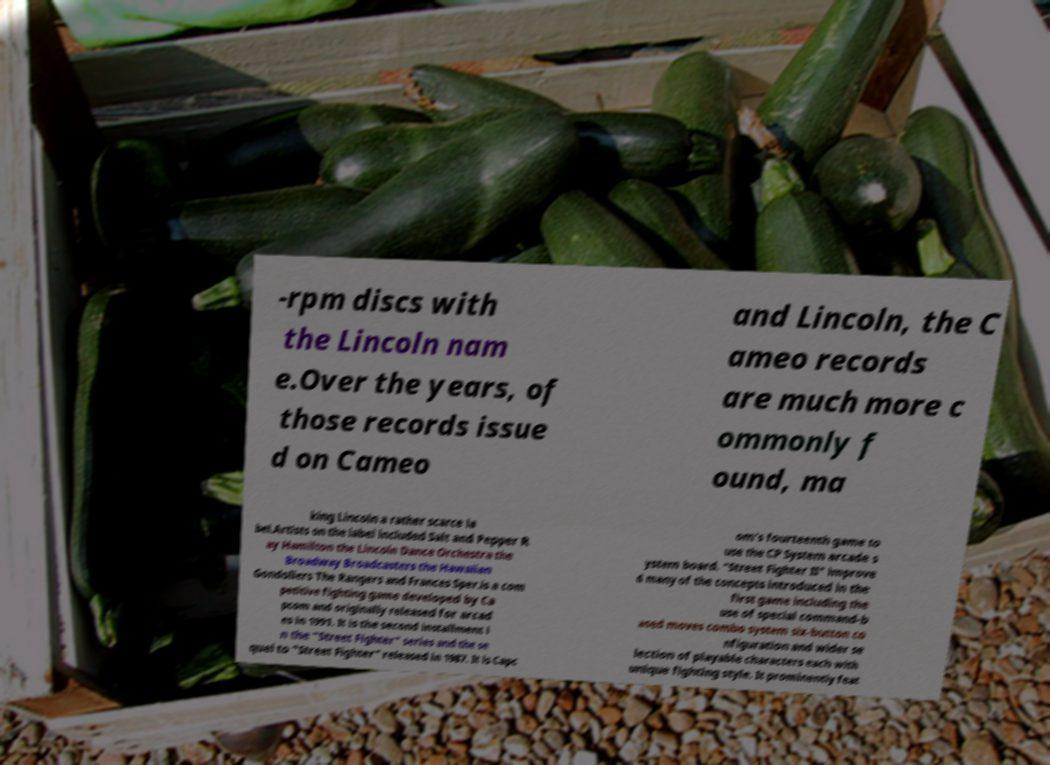Can you read and provide the text displayed in the image?This photo seems to have some interesting text. Can you extract and type it out for me? -rpm discs with the Lincoln nam e.Over the years, of those records issue d on Cameo and Lincoln, the C ameo records are much more c ommonly f ound, ma king Lincoln a rather scarce la bel.Artists on the label included Salt and Pepper R ay Hamilton the Lincoln Dance Orchestra the Broadway Broadcasters the Hawaiian Gondoliers The Rangers and Frances Sper.is a com petitive fighting game developed by Ca pcom and originally released for arcad es in 1991. It is the second installment i n the "Street Fighter" series and the se quel to "Street Fighter" released in 1987. It is Capc om's fourteenth game to use the CP System arcade s ystem board. "Street Fighter II" improve d many of the concepts introduced in the first game including the use of special command-b ased moves combo system six-button co nfiguration and wider se lection of playable characters each with unique fighting style. It prominently feat 